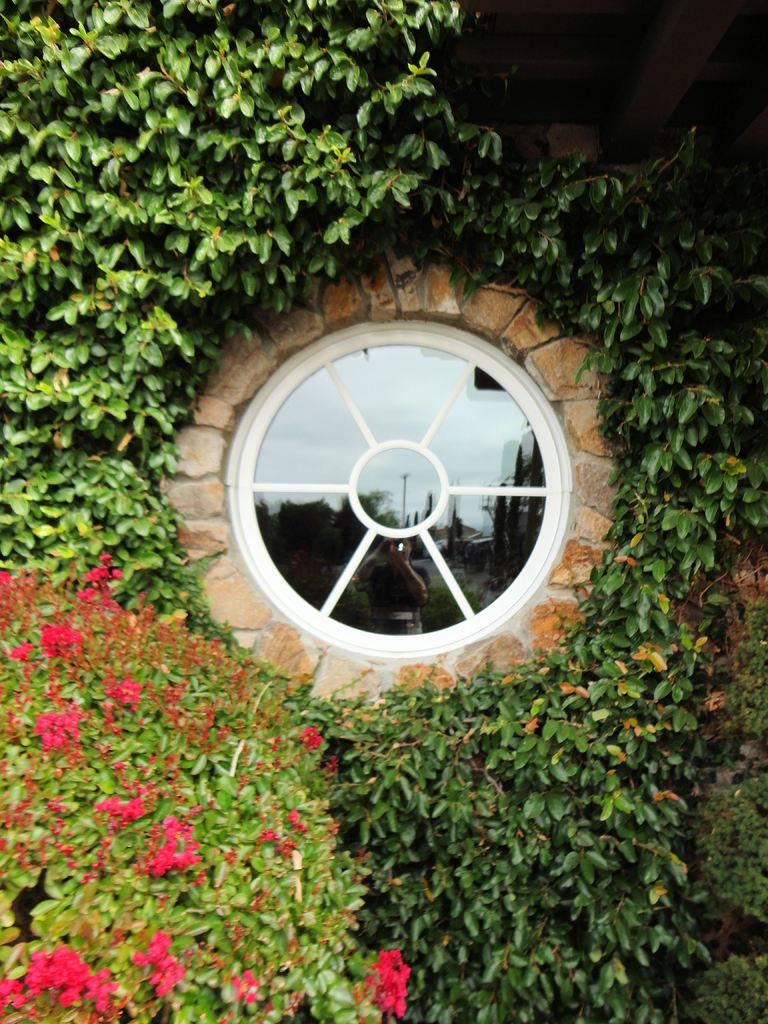What is the primary element visible in the image? There are many leaves in the image. What can be seen on the wall in the image? There are flowers and a round shape with a glass object on the wall in the image. How many sheep are visible in the image? There are no sheep present in the image. What type of camera is being used to capture the image? The image itself does not provide information about the camera used to capture it. 